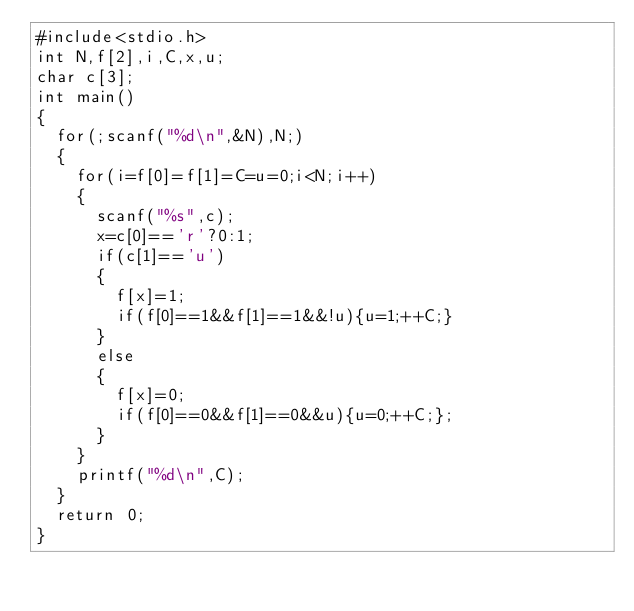<code> <loc_0><loc_0><loc_500><loc_500><_C_>#include<stdio.h>
int N,f[2],i,C,x,u;
char c[3];
int main()
{
	for(;scanf("%d\n",&N),N;)
	{
		for(i=f[0]=f[1]=C=u=0;i<N;i++)
		{
			scanf("%s",c);
			x=c[0]=='r'?0:1;
			if(c[1]=='u')
			{
				f[x]=1;
				if(f[0]==1&&f[1]==1&&!u){u=1;++C;}
			}
			else
			{
				f[x]=0;
				if(f[0]==0&&f[1]==0&&u){u=0;++C;};
			}
		}
		printf("%d\n",C);
	}
	return 0;
}</code> 